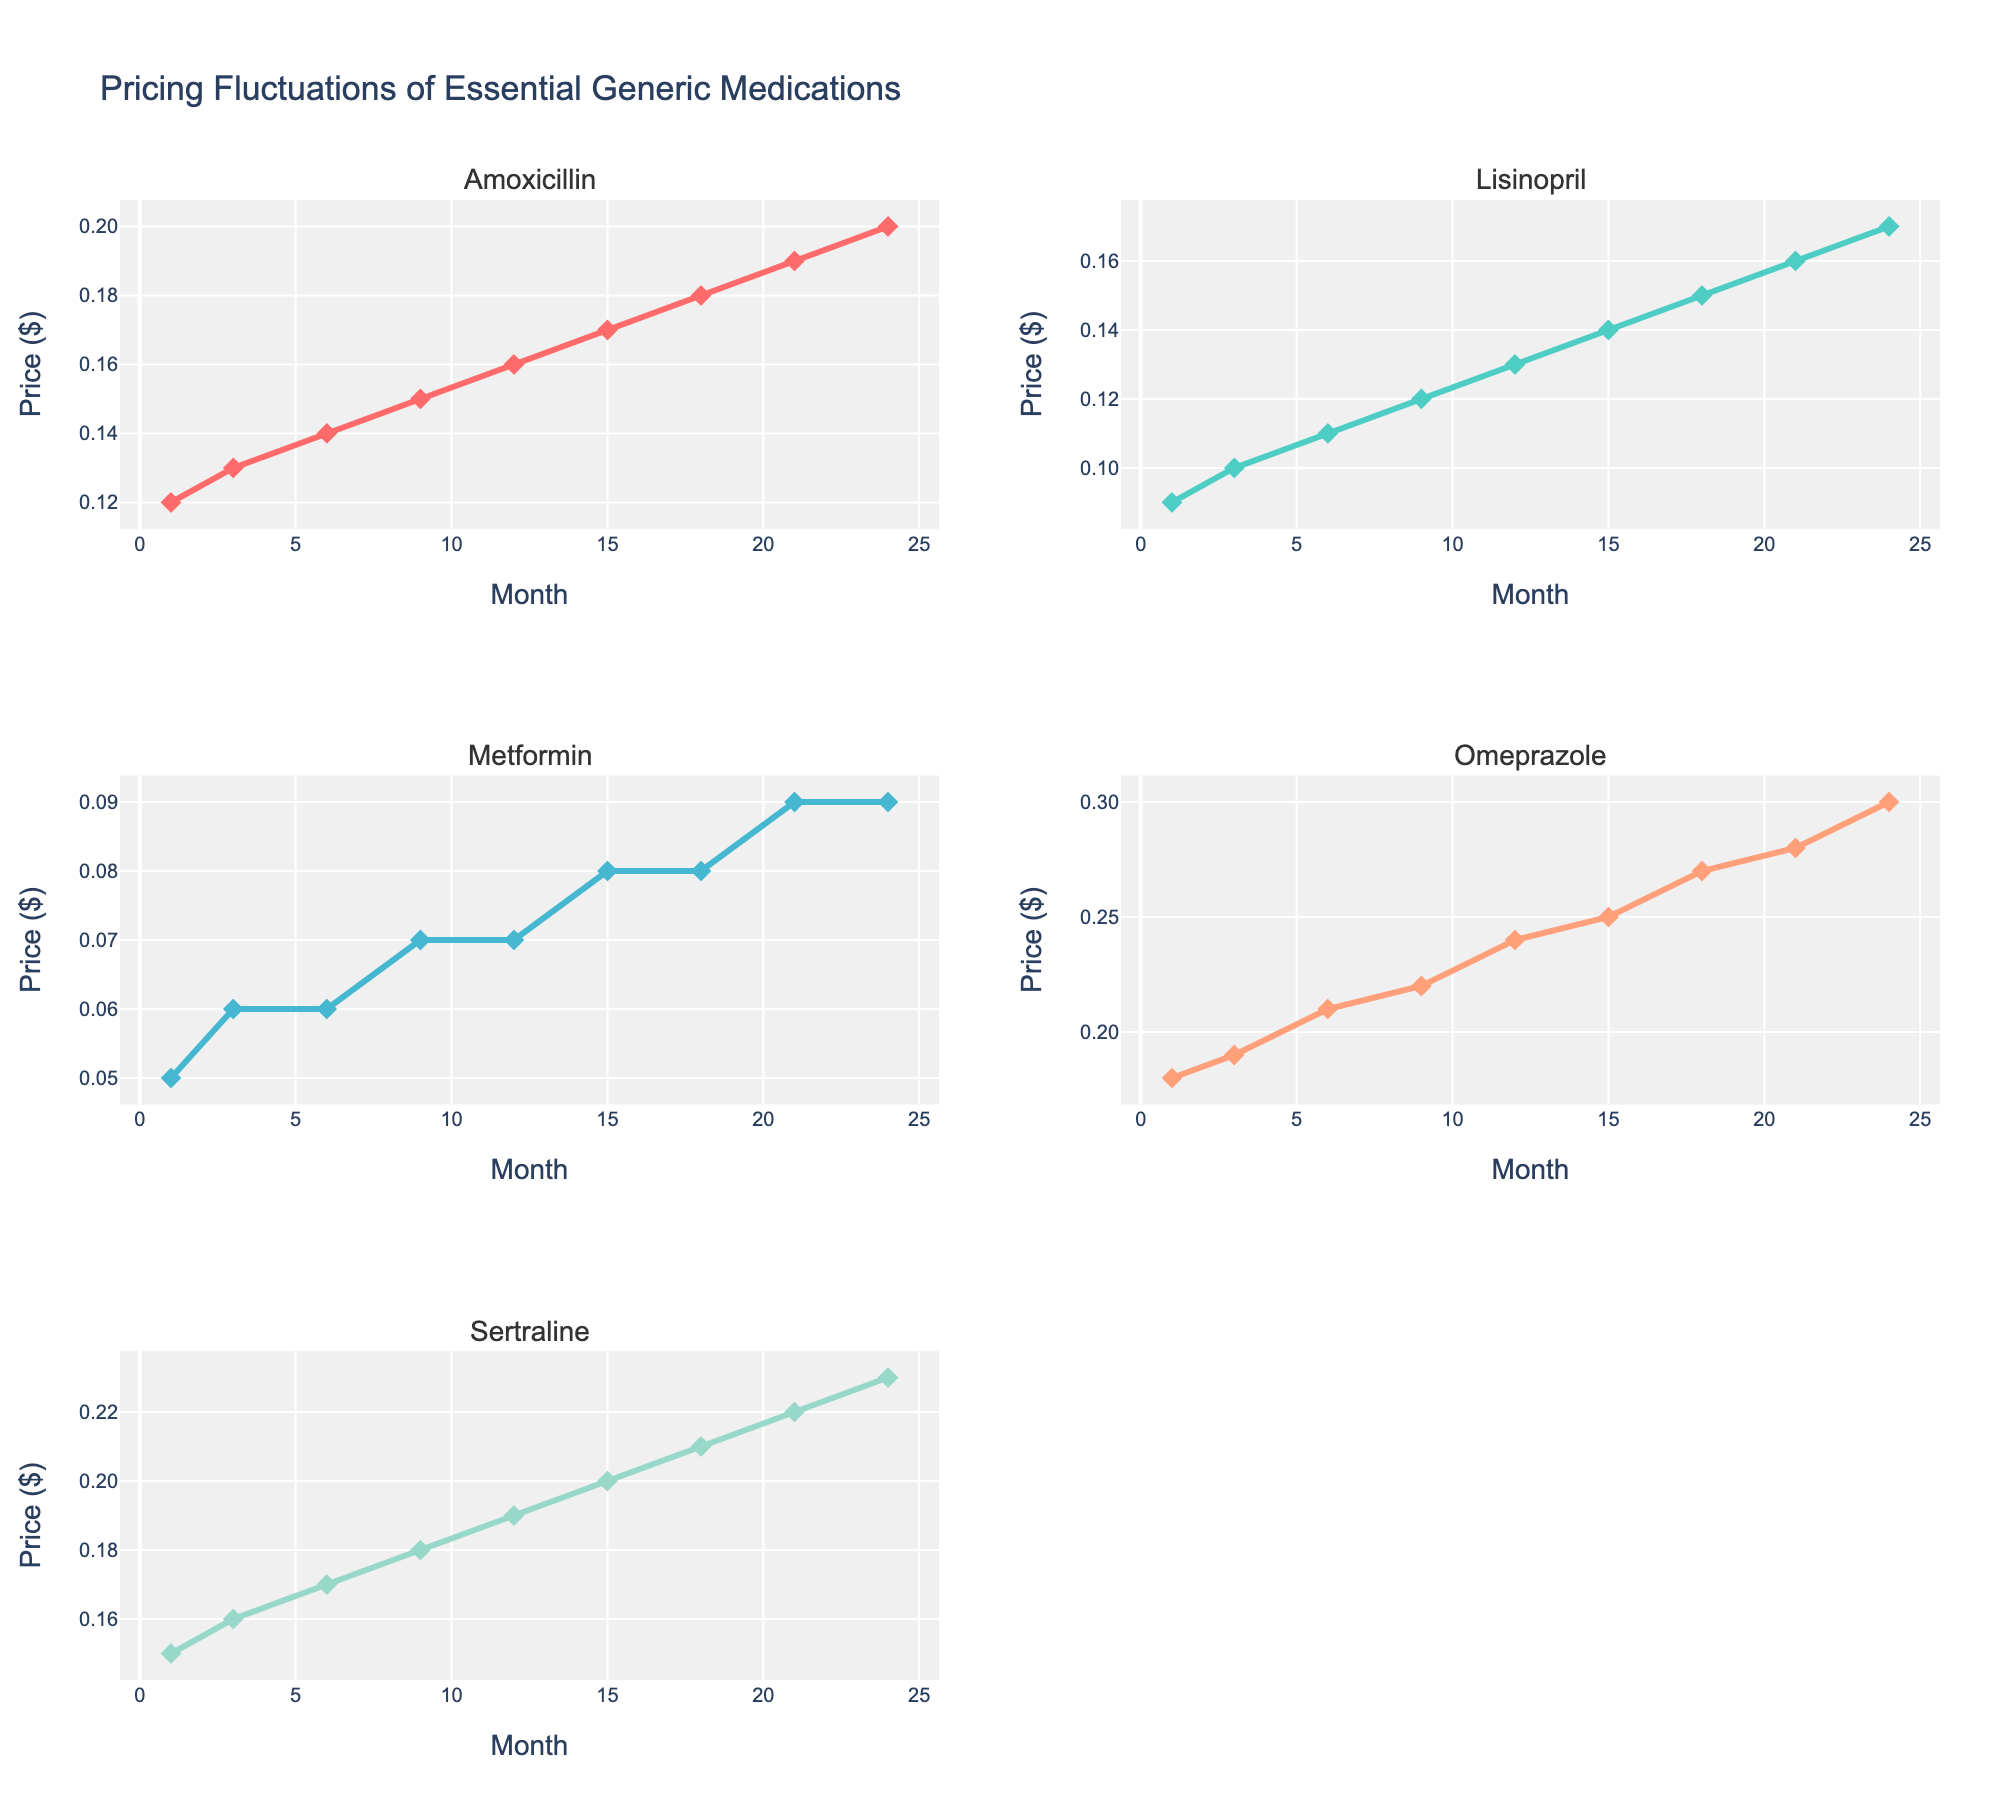How many medications are displayed in the figure? The figure contains subplots, each corresponding to a different medication. By counting the subplot titles, we can identify the number of medications shown.
Answer: 5 What is the title of the figure? The title is typically at the top of the figure and summarizes the content of the entire dataset.
Answer: Pricing Fluctuations of Essential Generic Medications Which medication shows the largest price increase over the 24 months? By analyzing the endpoints of each line in the subplots, we can visually compare the price changes. The largest increase is visible by comparing the starting and ending values for each medication. In this case, Omeprazole shows the largest price increase from 0.18 to 0.30 dollars.
Answer: Omeprazole Which medication has the smallest price fluctuation over the 24 months? To determine the medication with the smallest price fluctuation, we need to compare the range of price changes for each medication. The smallest difference between the maximum and minimum values during the 24 months indicates the smallest fluctuation.
Answer: Metformin What is the price difference of Lisinopril between month 1 and month 24? Locate the price of Lisinopril at month 1 and month 24 from its subplot and subtract the earlier price from the later price. The values are 0.09 and 0.17 respectively. So, 0.17 - 0.09 = 0.08.
Answer: 0.08 For which months do we have data points recorded? Data points are marked along the x-axis of each subplot. By observing these markers, we can identify the specific months when data was recorded.
Answer: 1, 3, 6, 9, 12, 15, 18, 21, 24 How does Amoxicillin's price trend over time compare to Sertraline's? By comparing the lines in the respective subplots, we observe that both prices increase over time, but Amoxicillin has a more gradual increase whereas Sertraline also increases steadily but starts and ends at higher prices.
Answer: Both increase; Amoxicillin gradually, Sertraline steadily What is the average price of Metformin over the 24 months? Sum the recorded prices of Metformin and divide by the number of data points. The values are 0.05, 0.06, 0.06, 0.07, 0.07, 0.08, 0.08, 0.09, summing to 0.56. Dividing by 8 data points gives an average of 0.07.
Answer: 0.07 Which medication had the smallest price increase between months 12 and 24? Comparing price increments for all medications from month 12 to month 24, we calculate the differences and find that Metformin increased the least, from 0.07 to 0.09, which is 0.02.
Answer: Metformin 